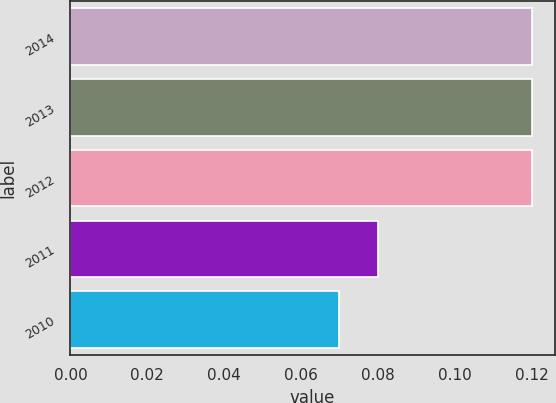Convert chart. <chart><loc_0><loc_0><loc_500><loc_500><bar_chart><fcel>2014<fcel>2013<fcel>2012<fcel>2011<fcel>2010<nl><fcel>0.12<fcel>0.12<fcel>0.12<fcel>0.08<fcel>0.07<nl></chart> 